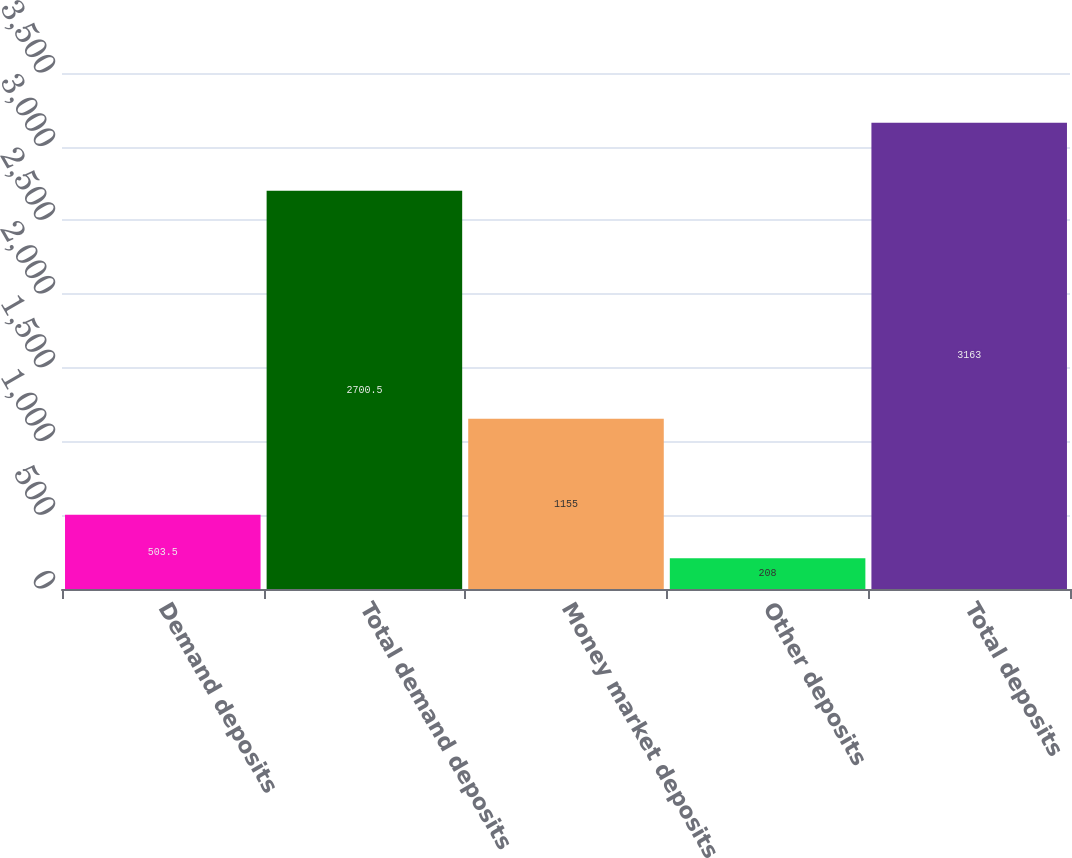Convert chart. <chart><loc_0><loc_0><loc_500><loc_500><bar_chart><fcel>Demand deposits<fcel>Total demand deposits<fcel>Money market deposits<fcel>Other deposits<fcel>Total deposits<nl><fcel>503.5<fcel>2700.5<fcel>1155<fcel>208<fcel>3163<nl></chart> 